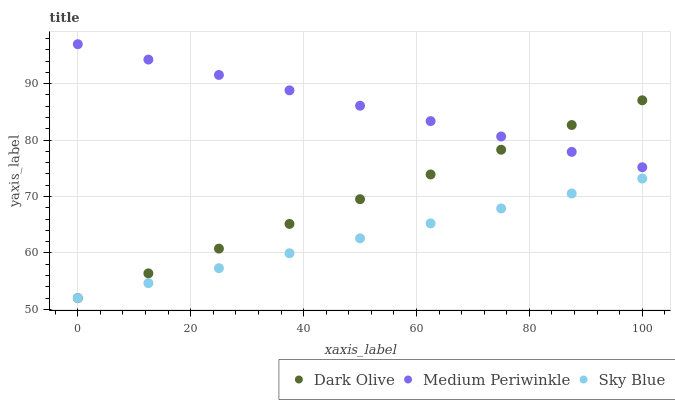Does Sky Blue have the minimum area under the curve?
Answer yes or no. Yes. Does Medium Periwinkle have the maximum area under the curve?
Answer yes or no. Yes. Does Dark Olive have the minimum area under the curve?
Answer yes or no. No. Does Dark Olive have the maximum area under the curve?
Answer yes or no. No. Is Medium Periwinkle the smoothest?
Answer yes or no. Yes. Is Dark Olive the roughest?
Answer yes or no. Yes. Is Dark Olive the smoothest?
Answer yes or no. No. Is Medium Periwinkle the roughest?
Answer yes or no. No. Does Sky Blue have the lowest value?
Answer yes or no. Yes. Does Medium Periwinkle have the lowest value?
Answer yes or no. No. Does Medium Periwinkle have the highest value?
Answer yes or no. Yes. Does Dark Olive have the highest value?
Answer yes or no. No. Is Sky Blue less than Medium Periwinkle?
Answer yes or no. Yes. Is Medium Periwinkle greater than Sky Blue?
Answer yes or no. Yes. Does Sky Blue intersect Dark Olive?
Answer yes or no. Yes. Is Sky Blue less than Dark Olive?
Answer yes or no. No. Is Sky Blue greater than Dark Olive?
Answer yes or no. No. Does Sky Blue intersect Medium Periwinkle?
Answer yes or no. No. 